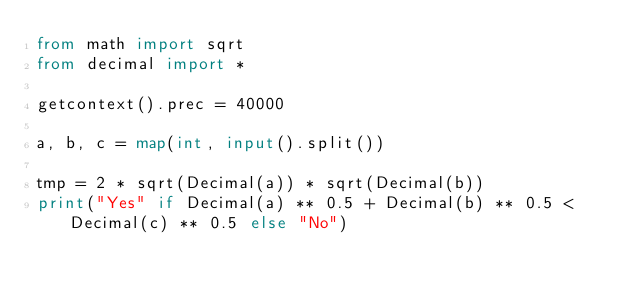Convert code to text. <code><loc_0><loc_0><loc_500><loc_500><_Python_>from math import sqrt
from decimal import *

getcontext().prec = 40000

a, b, c = map(int, input().split())

tmp = 2 * sqrt(Decimal(a)) * sqrt(Decimal(b))
print("Yes" if Decimal(a) ** 0.5 + Decimal(b) ** 0.5 < Decimal(c) ** 0.5 else "No")
</code> 